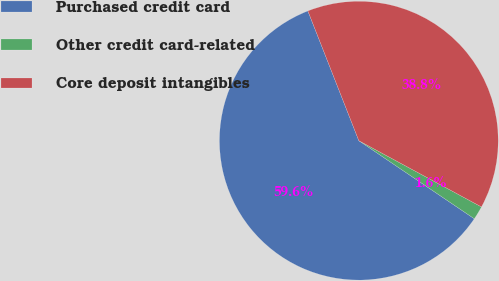<chart> <loc_0><loc_0><loc_500><loc_500><pie_chart><fcel>Purchased credit card<fcel>Other credit card-related<fcel>Core deposit intangibles<nl><fcel>59.58%<fcel>1.58%<fcel>38.84%<nl></chart> 